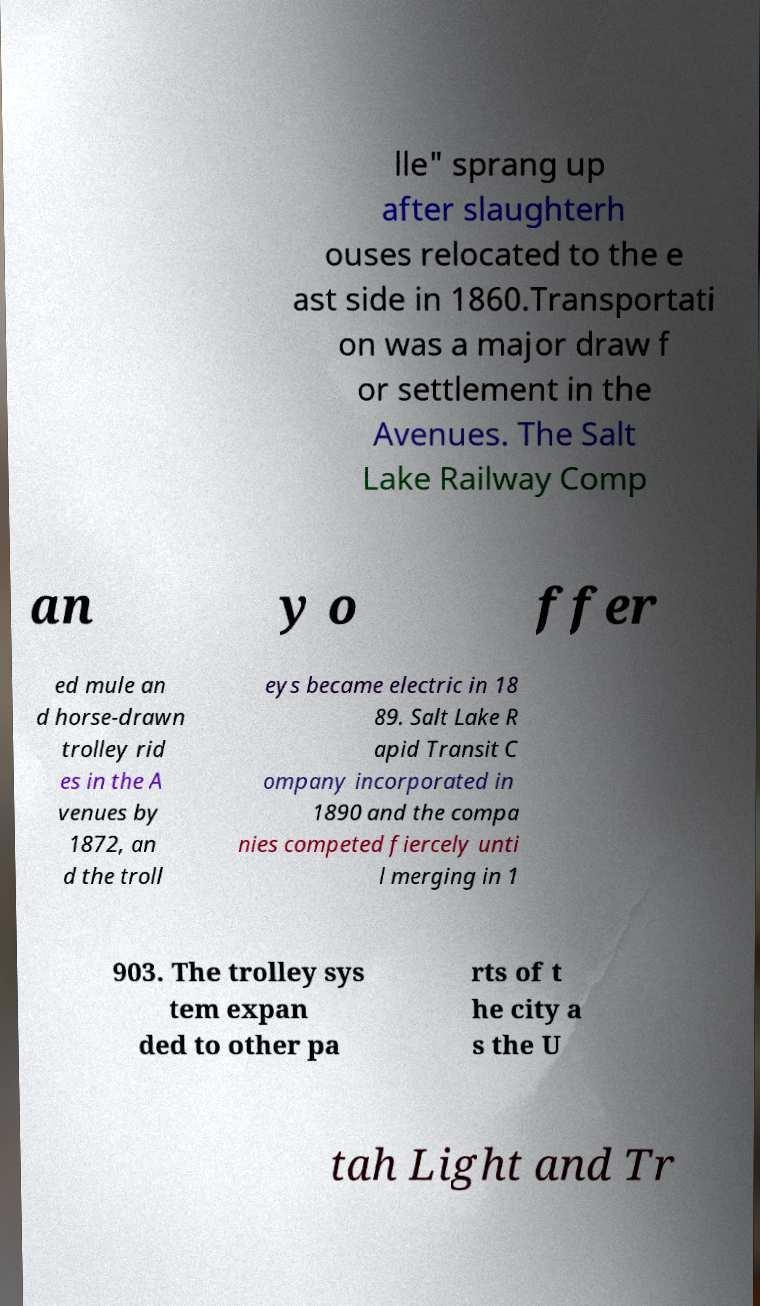Can you read and provide the text displayed in the image?This photo seems to have some interesting text. Can you extract and type it out for me? lle" sprang up after slaughterh ouses relocated to the e ast side in 1860.Transportati on was a major draw f or settlement in the Avenues. The Salt Lake Railway Comp an y o ffer ed mule an d horse-drawn trolley rid es in the A venues by 1872, an d the troll eys became electric in 18 89. Salt Lake R apid Transit C ompany incorporated in 1890 and the compa nies competed fiercely unti l merging in 1 903. The trolley sys tem expan ded to other pa rts of t he city a s the U tah Light and Tr 